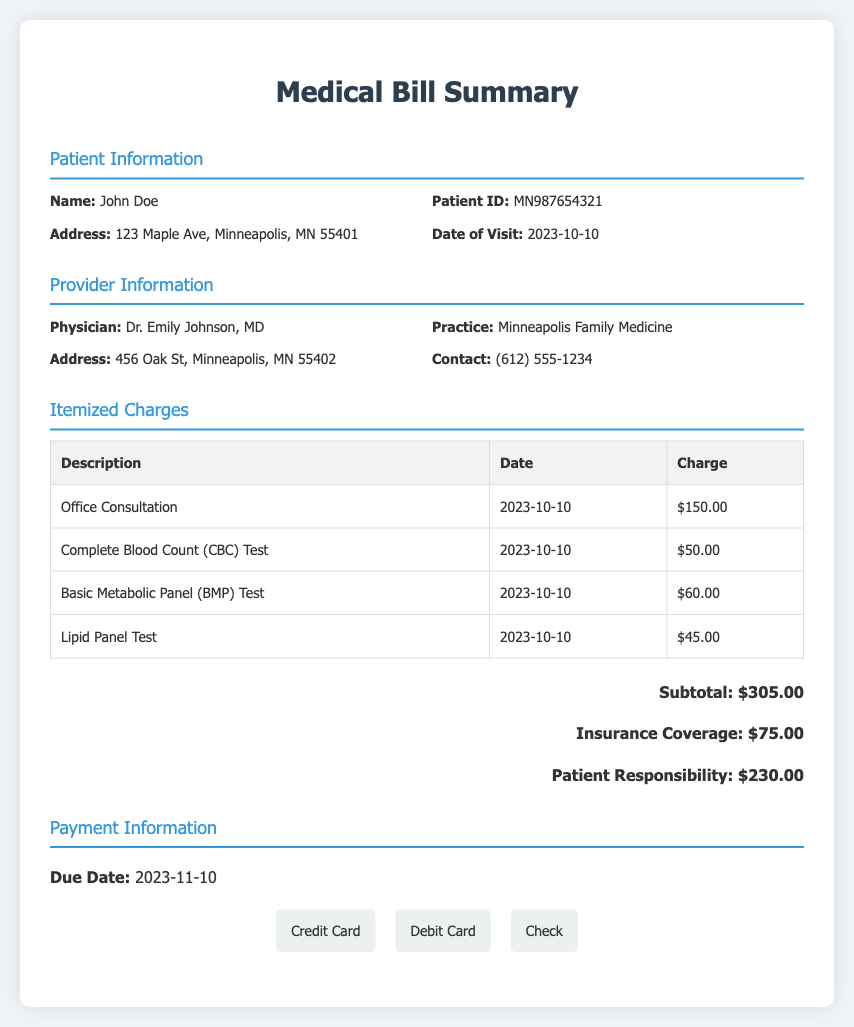What is the patient's name? The document states the patient's name in the Patient Information section.
Answer: John Doe What is the total charge before insurance coverage? The subtotal is listed in the Itemized Charges section, which details all charges.
Answer: $305.00 Who is the physician? The provider information section identifies the physician for this medical visit.
Answer: Dr. Emily Johnson, MD What is the date of the doctor's visit? The date is found in the Patient Information section.
Answer: 2023-10-10 How much does the patient owe after insurance? The patient responsibility is clearly mentioned in the Itemized Charges section.
Answer: $230.00 What is the due date for the payment? The payment information section provides the due date.
Answer: 2023-11-10 How many tests were performed during the visit? By counting the line items in the Itemized Charges table, we can determine the number of tests.
Answer: 3 What is the insurance coverage amount? The insurance coverage is explicitly mentioned in the total section of itemized charges.
Answer: $75.00 What is the address of the physician's practice? The address can be found in the Provider Information section next to the practice name.
Answer: 456 Oak St, Minneapolis, MN 55402 